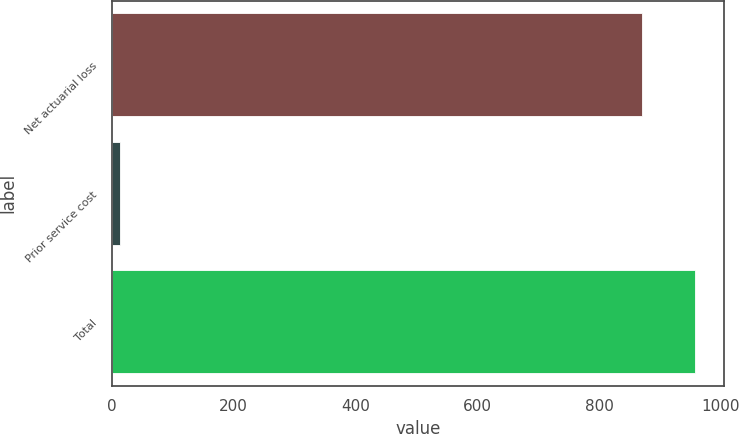<chart> <loc_0><loc_0><loc_500><loc_500><bar_chart><fcel>Net actuarial loss<fcel>Prior service cost<fcel>Total<nl><fcel>869.8<fcel>13.7<fcel>956.78<nl></chart> 